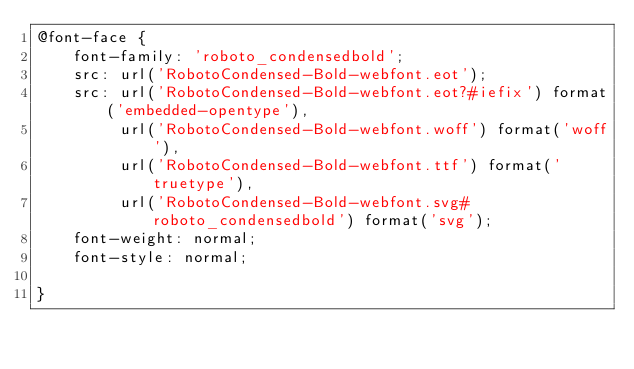Convert code to text. <code><loc_0><loc_0><loc_500><loc_500><_CSS_>@font-face {
    font-family: 'roboto_condensedbold';
    src: url('RobotoCondensed-Bold-webfont.eot');
    src: url('RobotoCondensed-Bold-webfont.eot?#iefix') format('embedded-opentype'),
         url('RobotoCondensed-Bold-webfont.woff') format('woff'),
         url('RobotoCondensed-Bold-webfont.ttf') format('truetype'),
         url('RobotoCondensed-Bold-webfont.svg#roboto_condensedbold') format('svg');
    font-weight: normal;
    font-style: normal;

}

</code> 